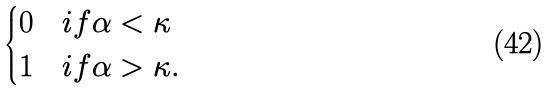<formula> <loc_0><loc_0><loc_500><loc_500>\begin{cases} 0 & i f \alpha < \kappa \\ 1 & i f \alpha > \kappa . \end{cases}</formula> 